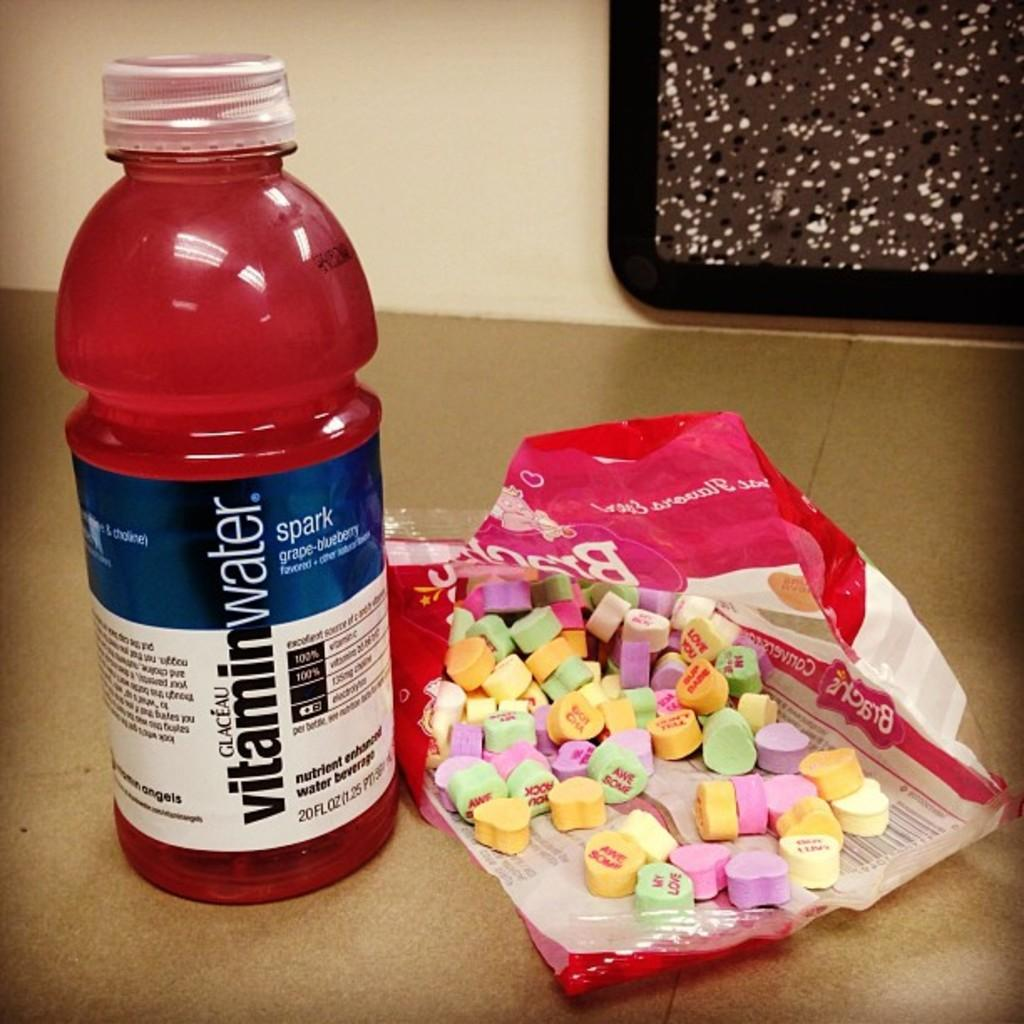Provide a one-sentence caption for the provided image. A bottle of red vitamin water sits next to an open bag of unhealthy looking candy. 